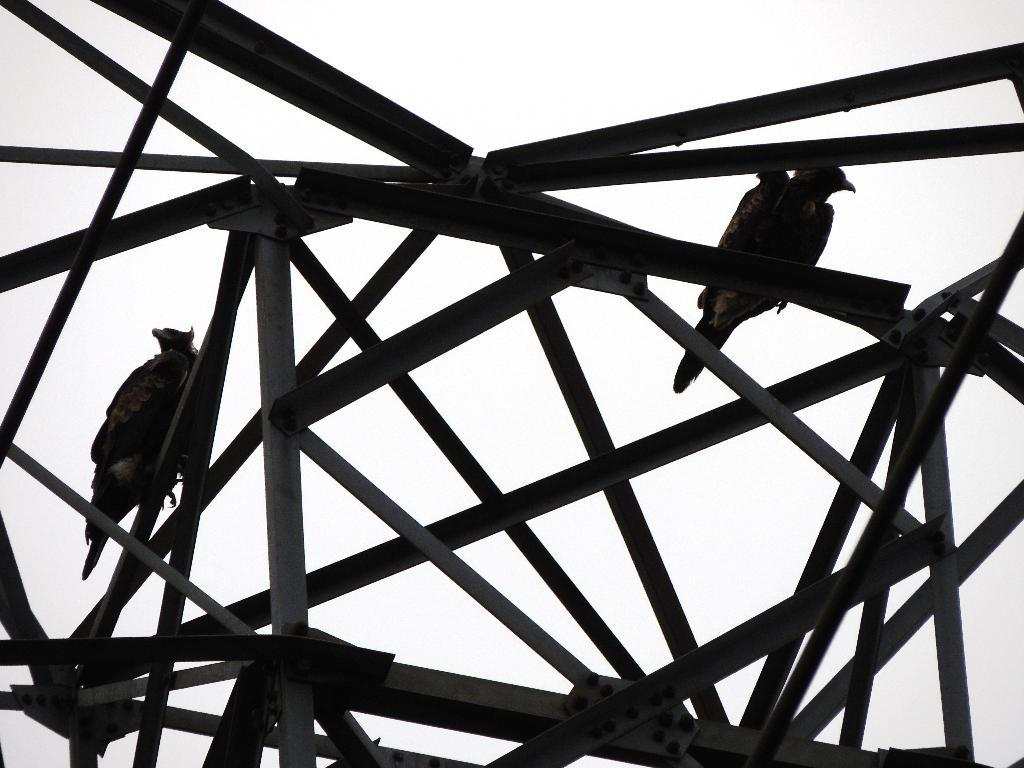What is the color scheme of the image? The image is black and white. What can be seen on the poles in the image? There are birds on poles in the image. What is visible in the background of the image? The sky is visible in the background of the image. How does the sky appear in the image? The sky looks cloudy in the image. What type of support can be seen in the image? There is no specific support structure visible in the image; it primarily features birds on poles and a cloudy sky. Can you tell me how many tombstones are present in the image? There are no tombstones or cemetery elements present in the image; it focuses on birds on poles and the sky. 